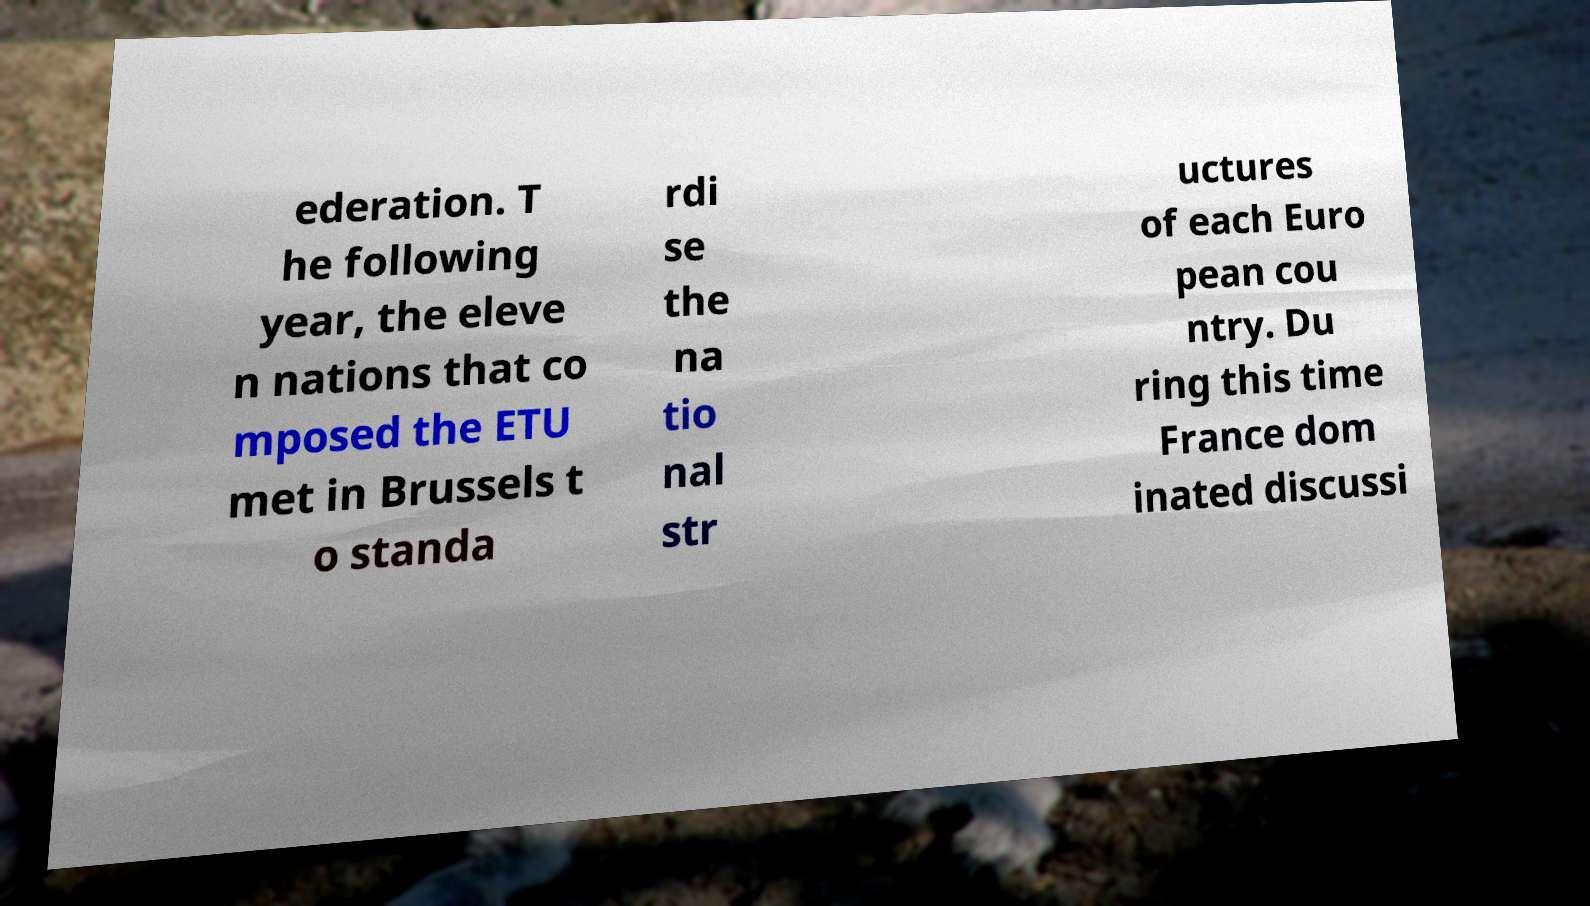Could you assist in decoding the text presented in this image and type it out clearly? ederation. T he following year, the eleve n nations that co mposed the ETU met in Brussels t o standa rdi se the na tio nal str uctures of each Euro pean cou ntry. Du ring this time France dom inated discussi 